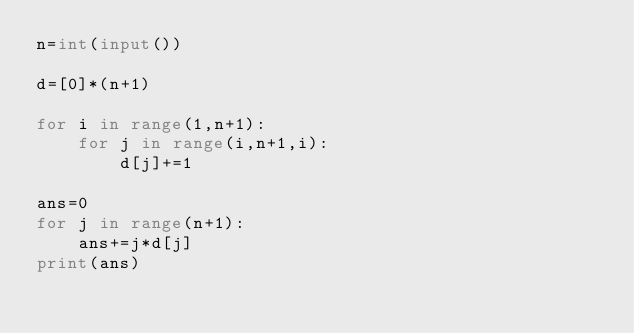Convert code to text. <code><loc_0><loc_0><loc_500><loc_500><_Python_>n=int(input())

d=[0]*(n+1)

for i in range(1,n+1):
    for j in range(i,n+1,i):
        d[j]+=1
        
ans=0
for j in range(n+1):
    ans+=j*d[j]
print(ans)</code> 